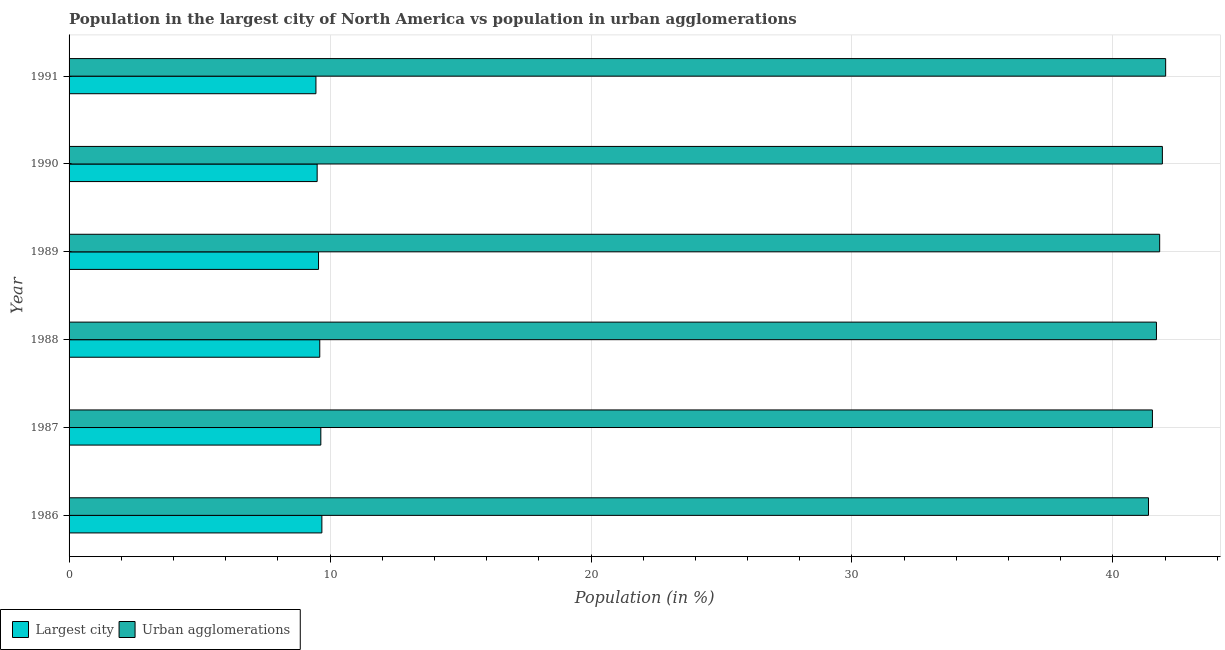How many different coloured bars are there?
Your answer should be compact. 2. How many groups of bars are there?
Your answer should be very brief. 6. How many bars are there on the 6th tick from the top?
Ensure brevity in your answer.  2. How many bars are there on the 1st tick from the bottom?
Provide a short and direct response. 2. What is the label of the 5th group of bars from the top?
Give a very brief answer. 1987. What is the population in the largest city in 1986?
Keep it short and to the point. 9.69. Across all years, what is the maximum population in urban agglomerations?
Ensure brevity in your answer.  42.02. Across all years, what is the minimum population in urban agglomerations?
Offer a very short reply. 41.36. What is the total population in urban agglomerations in the graph?
Offer a very short reply. 250.25. What is the difference between the population in urban agglomerations in 1987 and the population in the largest city in 1986?
Your response must be concise. 31.83. What is the average population in urban agglomerations per year?
Your answer should be very brief. 41.71. In the year 1990, what is the difference between the population in the largest city and population in urban agglomerations?
Your answer should be compact. -32.39. Is the population in urban agglomerations in 1988 less than that in 1989?
Give a very brief answer. Yes. Is the difference between the population in the largest city in 1986 and 1988 greater than the difference between the population in urban agglomerations in 1986 and 1988?
Your response must be concise. Yes. What is the difference between the highest and the second highest population in urban agglomerations?
Make the answer very short. 0.13. What is the difference between the highest and the lowest population in urban agglomerations?
Provide a short and direct response. 0.66. What does the 2nd bar from the top in 1986 represents?
Make the answer very short. Largest city. What does the 2nd bar from the bottom in 1991 represents?
Offer a terse response. Urban agglomerations. How many bars are there?
Make the answer very short. 12. Are all the bars in the graph horizontal?
Provide a succinct answer. Yes. How many years are there in the graph?
Make the answer very short. 6. What is the difference between two consecutive major ticks on the X-axis?
Provide a short and direct response. 10. Are the values on the major ticks of X-axis written in scientific E-notation?
Offer a terse response. No. How many legend labels are there?
Make the answer very short. 2. What is the title of the graph?
Your answer should be compact. Population in the largest city of North America vs population in urban agglomerations. Does "Borrowers" appear as one of the legend labels in the graph?
Your response must be concise. No. What is the Population (in %) of Largest city in 1986?
Your answer should be very brief. 9.69. What is the Population (in %) in Urban agglomerations in 1986?
Offer a terse response. 41.36. What is the Population (in %) in Largest city in 1987?
Provide a short and direct response. 9.65. What is the Population (in %) in Urban agglomerations in 1987?
Your answer should be compact. 41.51. What is the Population (in %) in Largest city in 1988?
Provide a short and direct response. 9.61. What is the Population (in %) of Urban agglomerations in 1988?
Ensure brevity in your answer.  41.67. What is the Population (in %) of Largest city in 1989?
Your answer should be very brief. 9.56. What is the Population (in %) of Urban agglomerations in 1989?
Your response must be concise. 41.79. What is the Population (in %) of Largest city in 1990?
Your answer should be very brief. 9.51. What is the Population (in %) of Urban agglomerations in 1990?
Keep it short and to the point. 41.89. What is the Population (in %) of Largest city in 1991?
Provide a short and direct response. 9.46. What is the Population (in %) in Urban agglomerations in 1991?
Provide a succinct answer. 42.02. Across all years, what is the maximum Population (in %) of Largest city?
Ensure brevity in your answer.  9.69. Across all years, what is the maximum Population (in %) in Urban agglomerations?
Keep it short and to the point. 42.02. Across all years, what is the minimum Population (in %) of Largest city?
Offer a terse response. 9.46. Across all years, what is the minimum Population (in %) of Urban agglomerations?
Make the answer very short. 41.36. What is the total Population (in %) in Largest city in the graph?
Offer a very short reply. 57.47. What is the total Population (in %) in Urban agglomerations in the graph?
Offer a terse response. 250.25. What is the difference between the Population (in %) of Largest city in 1986 and that in 1987?
Ensure brevity in your answer.  0.04. What is the difference between the Population (in %) in Urban agglomerations in 1986 and that in 1987?
Keep it short and to the point. -0.15. What is the difference between the Population (in %) in Largest city in 1986 and that in 1988?
Offer a very short reply. 0.08. What is the difference between the Population (in %) in Urban agglomerations in 1986 and that in 1988?
Your answer should be very brief. -0.3. What is the difference between the Population (in %) of Largest city in 1986 and that in 1989?
Ensure brevity in your answer.  0.13. What is the difference between the Population (in %) in Urban agglomerations in 1986 and that in 1989?
Provide a short and direct response. -0.43. What is the difference between the Population (in %) of Largest city in 1986 and that in 1990?
Provide a short and direct response. 0.18. What is the difference between the Population (in %) of Urban agglomerations in 1986 and that in 1990?
Make the answer very short. -0.53. What is the difference between the Population (in %) of Largest city in 1986 and that in 1991?
Offer a very short reply. 0.23. What is the difference between the Population (in %) of Urban agglomerations in 1986 and that in 1991?
Provide a short and direct response. -0.66. What is the difference between the Population (in %) of Largest city in 1987 and that in 1988?
Keep it short and to the point. 0.04. What is the difference between the Population (in %) of Urban agglomerations in 1987 and that in 1988?
Keep it short and to the point. -0.15. What is the difference between the Population (in %) of Largest city in 1987 and that in 1989?
Your answer should be very brief. 0.09. What is the difference between the Population (in %) in Urban agglomerations in 1987 and that in 1989?
Provide a succinct answer. -0.28. What is the difference between the Population (in %) in Largest city in 1987 and that in 1990?
Provide a succinct answer. 0.14. What is the difference between the Population (in %) of Urban agglomerations in 1987 and that in 1990?
Your answer should be compact. -0.38. What is the difference between the Population (in %) in Largest city in 1987 and that in 1991?
Make the answer very short. 0.19. What is the difference between the Population (in %) of Urban agglomerations in 1987 and that in 1991?
Your answer should be compact. -0.51. What is the difference between the Population (in %) in Largest city in 1988 and that in 1989?
Give a very brief answer. 0.05. What is the difference between the Population (in %) in Urban agglomerations in 1988 and that in 1989?
Your response must be concise. -0.12. What is the difference between the Population (in %) in Largest city in 1988 and that in 1990?
Offer a very short reply. 0.1. What is the difference between the Population (in %) in Urban agglomerations in 1988 and that in 1990?
Provide a short and direct response. -0.23. What is the difference between the Population (in %) in Largest city in 1988 and that in 1991?
Your response must be concise. 0.15. What is the difference between the Population (in %) of Urban agglomerations in 1988 and that in 1991?
Your answer should be compact. -0.35. What is the difference between the Population (in %) of Largest city in 1989 and that in 1990?
Provide a succinct answer. 0.05. What is the difference between the Population (in %) in Urban agglomerations in 1989 and that in 1990?
Provide a succinct answer. -0.1. What is the difference between the Population (in %) in Largest city in 1989 and that in 1991?
Provide a succinct answer. 0.1. What is the difference between the Population (in %) of Urban agglomerations in 1989 and that in 1991?
Ensure brevity in your answer.  -0.23. What is the difference between the Population (in %) in Largest city in 1990 and that in 1991?
Your answer should be very brief. 0.05. What is the difference between the Population (in %) of Urban agglomerations in 1990 and that in 1991?
Your answer should be compact. -0.13. What is the difference between the Population (in %) in Largest city in 1986 and the Population (in %) in Urban agglomerations in 1987?
Offer a very short reply. -31.83. What is the difference between the Population (in %) in Largest city in 1986 and the Population (in %) in Urban agglomerations in 1988?
Your response must be concise. -31.98. What is the difference between the Population (in %) in Largest city in 1986 and the Population (in %) in Urban agglomerations in 1989?
Provide a succinct answer. -32.1. What is the difference between the Population (in %) in Largest city in 1986 and the Population (in %) in Urban agglomerations in 1990?
Your response must be concise. -32.21. What is the difference between the Population (in %) of Largest city in 1986 and the Population (in %) of Urban agglomerations in 1991?
Offer a terse response. -32.33. What is the difference between the Population (in %) of Largest city in 1987 and the Population (in %) of Urban agglomerations in 1988?
Offer a terse response. -32.02. What is the difference between the Population (in %) of Largest city in 1987 and the Population (in %) of Urban agglomerations in 1989?
Ensure brevity in your answer.  -32.14. What is the difference between the Population (in %) of Largest city in 1987 and the Population (in %) of Urban agglomerations in 1990?
Give a very brief answer. -32.25. What is the difference between the Population (in %) in Largest city in 1987 and the Population (in %) in Urban agglomerations in 1991?
Offer a very short reply. -32.37. What is the difference between the Population (in %) in Largest city in 1988 and the Population (in %) in Urban agglomerations in 1989?
Your answer should be compact. -32.18. What is the difference between the Population (in %) in Largest city in 1988 and the Population (in %) in Urban agglomerations in 1990?
Give a very brief answer. -32.29. What is the difference between the Population (in %) in Largest city in 1988 and the Population (in %) in Urban agglomerations in 1991?
Give a very brief answer. -32.41. What is the difference between the Population (in %) in Largest city in 1989 and the Population (in %) in Urban agglomerations in 1990?
Keep it short and to the point. -32.34. What is the difference between the Population (in %) in Largest city in 1989 and the Population (in %) in Urban agglomerations in 1991?
Provide a succinct answer. -32.46. What is the difference between the Population (in %) in Largest city in 1990 and the Population (in %) in Urban agglomerations in 1991?
Make the answer very short. -32.51. What is the average Population (in %) in Largest city per year?
Your answer should be compact. 9.58. What is the average Population (in %) in Urban agglomerations per year?
Give a very brief answer. 41.71. In the year 1986, what is the difference between the Population (in %) of Largest city and Population (in %) of Urban agglomerations?
Keep it short and to the point. -31.67. In the year 1987, what is the difference between the Population (in %) in Largest city and Population (in %) in Urban agglomerations?
Provide a short and direct response. -31.87. In the year 1988, what is the difference between the Population (in %) of Largest city and Population (in %) of Urban agglomerations?
Provide a short and direct response. -32.06. In the year 1989, what is the difference between the Population (in %) in Largest city and Population (in %) in Urban agglomerations?
Your answer should be very brief. -32.23. In the year 1990, what is the difference between the Population (in %) of Largest city and Population (in %) of Urban agglomerations?
Offer a terse response. -32.39. In the year 1991, what is the difference between the Population (in %) of Largest city and Population (in %) of Urban agglomerations?
Your answer should be very brief. -32.56. What is the ratio of the Population (in %) in Largest city in 1986 to that in 1987?
Offer a terse response. 1. What is the ratio of the Population (in %) of Urban agglomerations in 1986 to that in 1987?
Provide a succinct answer. 1. What is the ratio of the Population (in %) in Largest city in 1986 to that in 1988?
Your response must be concise. 1.01. What is the ratio of the Population (in %) in Largest city in 1986 to that in 1989?
Provide a short and direct response. 1.01. What is the ratio of the Population (in %) of Urban agglomerations in 1986 to that in 1989?
Offer a terse response. 0.99. What is the ratio of the Population (in %) in Urban agglomerations in 1986 to that in 1990?
Provide a succinct answer. 0.99. What is the ratio of the Population (in %) in Largest city in 1986 to that in 1991?
Your response must be concise. 1.02. What is the ratio of the Population (in %) of Urban agglomerations in 1986 to that in 1991?
Your answer should be very brief. 0.98. What is the ratio of the Population (in %) of Largest city in 1987 to that in 1988?
Provide a short and direct response. 1. What is the ratio of the Population (in %) of Largest city in 1987 to that in 1989?
Offer a very short reply. 1.01. What is the ratio of the Population (in %) of Largest city in 1987 to that in 1990?
Your answer should be very brief. 1.01. What is the ratio of the Population (in %) in Urban agglomerations in 1987 to that in 1990?
Keep it short and to the point. 0.99. What is the ratio of the Population (in %) of Largest city in 1987 to that in 1991?
Provide a succinct answer. 1.02. What is the ratio of the Population (in %) of Urban agglomerations in 1987 to that in 1991?
Keep it short and to the point. 0.99. What is the ratio of the Population (in %) in Largest city in 1988 to that in 1989?
Provide a succinct answer. 1. What is the ratio of the Population (in %) of Largest city in 1988 to that in 1990?
Offer a very short reply. 1.01. What is the ratio of the Population (in %) in Largest city in 1988 to that in 1991?
Your answer should be compact. 1.02. What is the ratio of the Population (in %) in Largest city in 1989 to that in 1990?
Give a very brief answer. 1.01. What is the ratio of the Population (in %) of Urban agglomerations in 1989 to that in 1990?
Make the answer very short. 1. What is the ratio of the Population (in %) of Largest city in 1989 to that in 1991?
Ensure brevity in your answer.  1.01. What is the difference between the highest and the second highest Population (in %) in Largest city?
Your response must be concise. 0.04. What is the difference between the highest and the second highest Population (in %) in Urban agglomerations?
Offer a very short reply. 0.13. What is the difference between the highest and the lowest Population (in %) in Largest city?
Give a very brief answer. 0.23. What is the difference between the highest and the lowest Population (in %) in Urban agglomerations?
Keep it short and to the point. 0.66. 